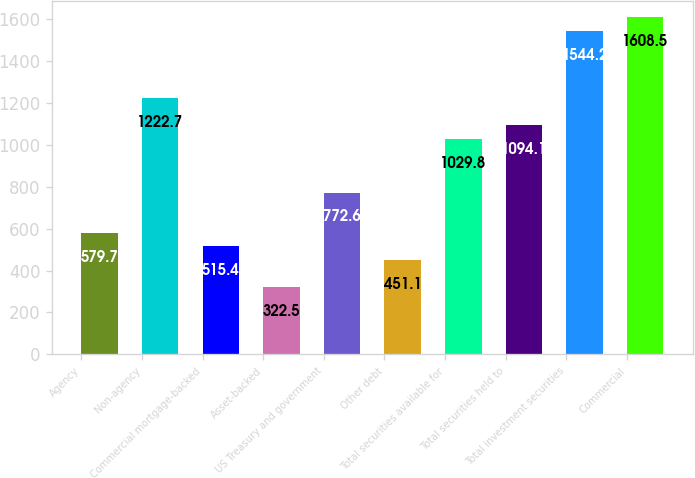Convert chart. <chart><loc_0><loc_0><loc_500><loc_500><bar_chart><fcel>Agency<fcel>Non-agency<fcel>Commercial mortgage-backed<fcel>Asset-backed<fcel>US Treasury and government<fcel>Other debt<fcel>Total securities available for<fcel>Total securities held to<fcel>Total investment securities<fcel>Commercial<nl><fcel>579.7<fcel>1222.7<fcel>515.4<fcel>322.5<fcel>772.6<fcel>451.1<fcel>1029.8<fcel>1094.1<fcel>1544.2<fcel>1608.5<nl></chart> 